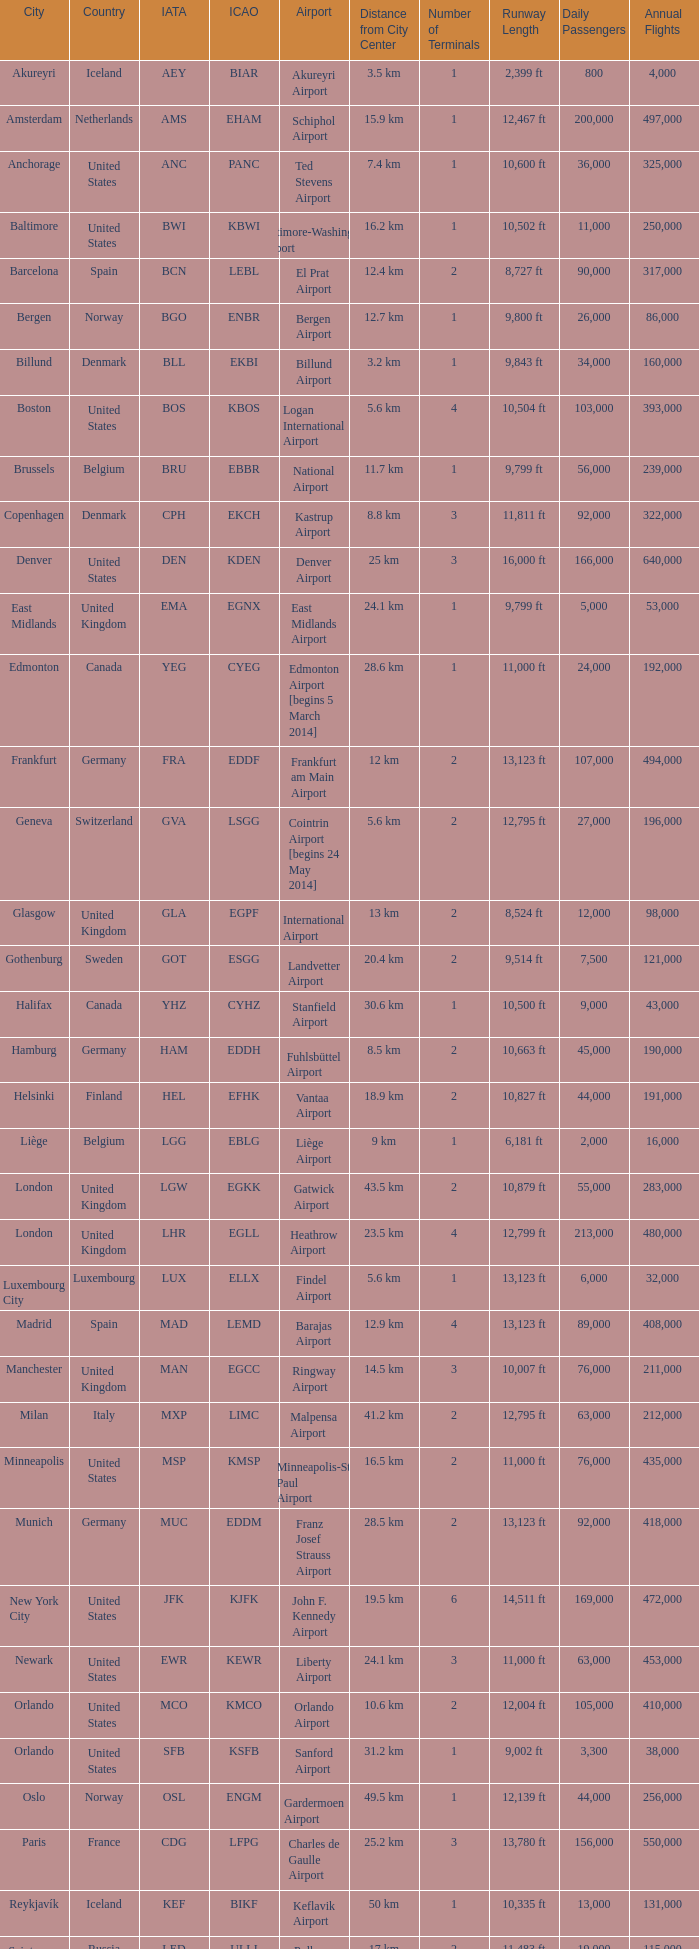Which airport possesses the icao identifier ksea? Seattle–Tacoma Airport. 